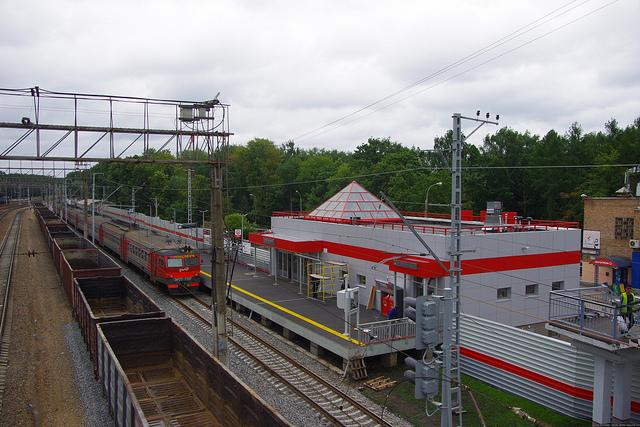These walls have a similar color scheme to what place? Please explain your reasoning. kfc. Kfc has a red and white color scheme. 